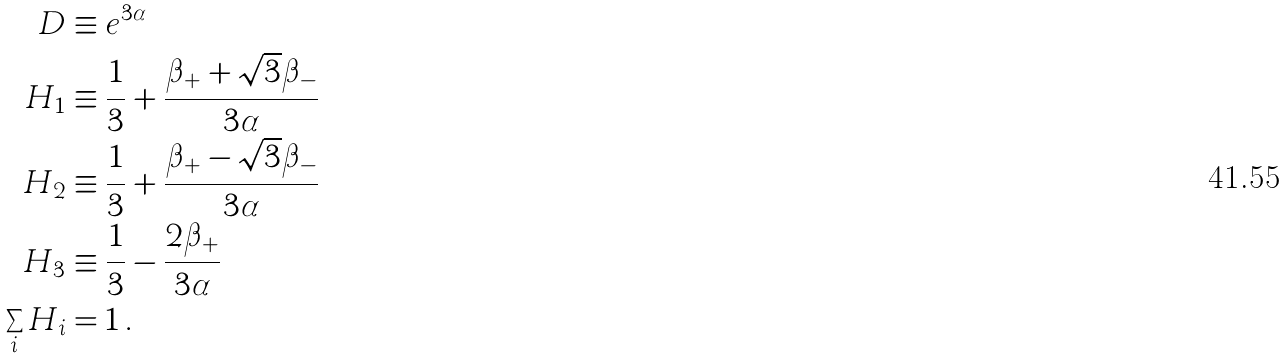<formula> <loc_0><loc_0><loc_500><loc_500>D & \equiv e ^ { 3 \alpha } \\ H _ { 1 } & \equiv \frac { 1 } { 3 } + \frac { \beta _ { + } + \sqrt { 3 } \beta _ { - } } { 3 \alpha } \\ H _ { 2 } & \equiv \frac { 1 } { 3 } + \frac { \beta _ { + } - \sqrt { 3 } \beta _ { - } } { 3 \alpha } \\ H _ { 3 } & \equiv \frac { 1 } { 3 } - \frac { 2 \beta _ { + } } { 3 \alpha } \\ \sum _ { i } H _ { i } & = 1 \, .</formula> 